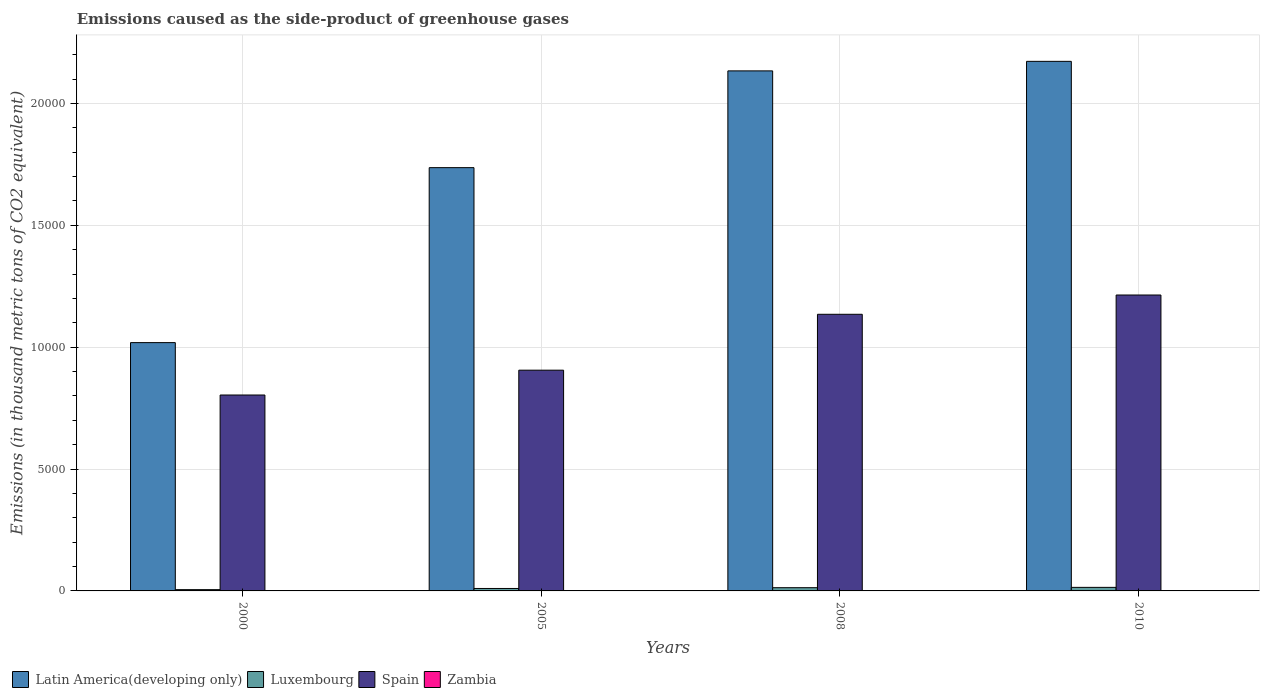How many different coloured bars are there?
Your answer should be very brief. 4. How many groups of bars are there?
Offer a terse response. 4. Are the number of bars on each tick of the X-axis equal?
Your answer should be compact. Yes. In how many cases, is the number of bars for a given year not equal to the number of legend labels?
Provide a short and direct response. 0. What is the emissions caused as the side-product of greenhouse gases in Spain in 2010?
Your answer should be compact. 1.21e+04. Across all years, what is the maximum emissions caused as the side-product of greenhouse gases in Latin America(developing only)?
Offer a terse response. 2.17e+04. What is the total emissions caused as the side-product of greenhouse gases in Zambia in the graph?
Your response must be concise. 2. What is the difference between the emissions caused as the side-product of greenhouse gases in Spain in 2000 and that in 2008?
Keep it short and to the point. -3310.7. What is the difference between the emissions caused as the side-product of greenhouse gases in Latin America(developing only) in 2008 and the emissions caused as the side-product of greenhouse gases in Spain in 2010?
Your answer should be very brief. 9193.8. What is the average emissions caused as the side-product of greenhouse gases in Luxembourg per year?
Offer a very short reply. 107.78. In the year 2005, what is the difference between the emissions caused as the side-product of greenhouse gases in Luxembourg and emissions caused as the side-product of greenhouse gases in Spain?
Make the answer very short. -8954.5. What is the ratio of the emissions caused as the side-product of greenhouse gases in Latin America(developing only) in 2005 to that in 2010?
Give a very brief answer. 0.8. What is the difference between the highest and the second highest emissions caused as the side-product of greenhouse gases in Spain?
Offer a very short reply. 791.2. What is the difference between the highest and the lowest emissions caused as the side-product of greenhouse gases in Latin America(developing only)?
Provide a succinct answer. 1.15e+04. Is the sum of the emissions caused as the side-product of greenhouse gases in Latin America(developing only) in 2008 and 2010 greater than the maximum emissions caused as the side-product of greenhouse gases in Luxembourg across all years?
Keep it short and to the point. Yes. What does the 4th bar from the left in 2000 represents?
Keep it short and to the point. Zambia. What does the 3rd bar from the right in 2008 represents?
Your answer should be very brief. Luxembourg. How many bars are there?
Provide a succinct answer. 16. Are all the bars in the graph horizontal?
Offer a terse response. No. How many years are there in the graph?
Provide a succinct answer. 4. Are the values on the major ticks of Y-axis written in scientific E-notation?
Give a very brief answer. No. Does the graph contain any zero values?
Keep it short and to the point. No. How are the legend labels stacked?
Offer a very short reply. Horizontal. What is the title of the graph?
Give a very brief answer. Emissions caused as the side-product of greenhouse gases. Does "Low & middle income" appear as one of the legend labels in the graph?
Keep it short and to the point. No. What is the label or title of the X-axis?
Your answer should be compact. Years. What is the label or title of the Y-axis?
Give a very brief answer. Emissions (in thousand metric tons of CO2 equivalent). What is the Emissions (in thousand metric tons of CO2 equivalent) in Latin America(developing only) in 2000?
Ensure brevity in your answer.  1.02e+04. What is the Emissions (in thousand metric tons of CO2 equivalent) in Luxembourg in 2000?
Your answer should be very brief. 52.1. What is the Emissions (in thousand metric tons of CO2 equivalent) in Spain in 2000?
Ensure brevity in your answer.  8037.1. What is the Emissions (in thousand metric tons of CO2 equivalent) in Latin America(developing only) in 2005?
Your response must be concise. 1.74e+04. What is the Emissions (in thousand metric tons of CO2 equivalent) in Luxembourg in 2005?
Provide a succinct answer. 100.6. What is the Emissions (in thousand metric tons of CO2 equivalent) of Spain in 2005?
Provide a short and direct response. 9055.1. What is the Emissions (in thousand metric tons of CO2 equivalent) in Zambia in 2005?
Give a very brief answer. 0.4. What is the Emissions (in thousand metric tons of CO2 equivalent) of Latin America(developing only) in 2008?
Provide a succinct answer. 2.13e+04. What is the Emissions (in thousand metric tons of CO2 equivalent) of Luxembourg in 2008?
Your answer should be compact. 132.4. What is the Emissions (in thousand metric tons of CO2 equivalent) of Spain in 2008?
Give a very brief answer. 1.13e+04. What is the Emissions (in thousand metric tons of CO2 equivalent) in Latin America(developing only) in 2010?
Keep it short and to the point. 2.17e+04. What is the Emissions (in thousand metric tons of CO2 equivalent) in Luxembourg in 2010?
Provide a succinct answer. 146. What is the Emissions (in thousand metric tons of CO2 equivalent) of Spain in 2010?
Your answer should be very brief. 1.21e+04. Across all years, what is the maximum Emissions (in thousand metric tons of CO2 equivalent) of Latin America(developing only)?
Your response must be concise. 2.17e+04. Across all years, what is the maximum Emissions (in thousand metric tons of CO2 equivalent) of Luxembourg?
Give a very brief answer. 146. Across all years, what is the maximum Emissions (in thousand metric tons of CO2 equivalent) of Spain?
Make the answer very short. 1.21e+04. Across all years, what is the maximum Emissions (in thousand metric tons of CO2 equivalent) of Zambia?
Offer a very short reply. 1. Across all years, what is the minimum Emissions (in thousand metric tons of CO2 equivalent) of Latin America(developing only)?
Your answer should be compact. 1.02e+04. Across all years, what is the minimum Emissions (in thousand metric tons of CO2 equivalent) of Luxembourg?
Your answer should be compact. 52.1. Across all years, what is the minimum Emissions (in thousand metric tons of CO2 equivalent) of Spain?
Provide a short and direct response. 8037.1. Across all years, what is the minimum Emissions (in thousand metric tons of CO2 equivalent) in Zambia?
Provide a succinct answer. 0.1. What is the total Emissions (in thousand metric tons of CO2 equivalent) in Latin America(developing only) in the graph?
Provide a succinct answer. 7.06e+04. What is the total Emissions (in thousand metric tons of CO2 equivalent) in Luxembourg in the graph?
Provide a succinct answer. 431.1. What is the total Emissions (in thousand metric tons of CO2 equivalent) of Spain in the graph?
Give a very brief answer. 4.06e+04. What is the difference between the Emissions (in thousand metric tons of CO2 equivalent) in Latin America(developing only) in 2000 and that in 2005?
Make the answer very short. -7177.9. What is the difference between the Emissions (in thousand metric tons of CO2 equivalent) of Luxembourg in 2000 and that in 2005?
Offer a terse response. -48.5. What is the difference between the Emissions (in thousand metric tons of CO2 equivalent) in Spain in 2000 and that in 2005?
Give a very brief answer. -1018. What is the difference between the Emissions (in thousand metric tons of CO2 equivalent) in Latin America(developing only) in 2000 and that in 2008?
Keep it short and to the point. -1.11e+04. What is the difference between the Emissions (in thousand metric tons of CO2 equivalent) of Luxembourg in 2000 and that in 2008?
Provide a succinct answer. -80.3. What is the difference between the Emissions (in thousand metric tons of CO2 equivalent) of Spain in 2000 and that in 2008?
Provide a short and direct response. -3310.7. What is the difference between the Emissions (in thousand metric tons of CO2 equivalent) in Zambia in 2000 and that in 2008?
Ensure brevity in your answer.  -0.4. What is the difference between the Emissions (in thousand metric tons of CO2 equivalent) in Latin America(developing only) in 2000 and that in 2010?
Keep it short and to the point. -1.15e+04. What is the difference between the Emissions (in thousand metric tons of CO2 equivalent) in Luxembourg in 2000 and that in 2010?
Provide a short and direct response. -93.9. What is the difference between the Emissions (in thousand metric tons of CO2 equivalent) of Spain in 2000 and that in 2010?
Offer a terse response. -4101.9. What is the difference between the Emissions (in thousand metric tons of CO2 equivalent) in Zambia in 2000 and that in 2010?
Your response must be concise. -0.9. What is the difference between the Emissions (in thousand metric tons of CO2 equivalent) of Latin America(developing only) in 2005 and that in 2008?
Your response must be concise. -3969.1. What is the difference between the Emissions (in thousand metric tons of CO2 equivalent) of Luxembourg in 2005 and that in 2008?
Ensure brevity in your answer.  -31.8. What is the difference between the Emissions (in thousand metric tons of CO2 equivalent) in Spain in 2005 and that in 2008?
Offer a very short reply. -2292.7. What is the difference between the Emissions (in thousand metric tons of CO2 equivalent) of Latin America(developing only) in 2005 and that in 2010?
Your answer should be compact. -4360.3. What is the difference between the Emissions (in thousand metric tons of CO2 equivalent) of Luxembourg in 2005 and that in 2010?
Your answer should be very brief. -45.4. What is the difference between the Emissions (in thousand metric tons of CO2 equivalent) of Spain in 2005 and that in 2010?
Your response must be concise. -3083.9. What is the difference between the Emissions (in thousand metric tons of CO2 equivalent) in Latin America(developing only) in 2008 and that in 2010?
Offer a terse response. -391.2. What is the difference between the Emissions (in thousand metric tons of CO2 equivalent) of Luxembourg in 2008 and that in 2010?
Your response must be concise. -13.6. What is the difference between the Emissions (in thousand metric tons of CO2 equivalent) in Spain in 2008 and that in 2010?
Offer a very short reply. -791.2. What is the difference between the Emissions (in thousand metric tons of CO2 equivalent) of Zambia in 2008 and that in 2010?
Provide a succinct answer. -0.5. What is the difference between the Emissions (in thousand metric tons of CO2 equivalent) in Latin America(developing only) in 2000 and the Emissions (in thousand metric tons of CO2 equivalent) in Luxembourg in 2005?
Your answer should be very brief. 1.01e+04. What is the difference between the Emissions (in thousand metric tons of CO2 equivalent) of Latin America(developing only) in 2000 and the Emissions (in thousand metric tons of CO2 equivalent) of Spain in 2005?
Your answer should be compact. 1130.7. What is the difference between the Emissions (in thousand metric tons of CO2 equivalent) in Latin America(developing only) in 2000 and the Emissions (in thousand metric tons of CO2 equivalent) in Zambia in 2005?
Offer a terse response. 1.02e+04. What is the difference between the Emissions (in thousand metric tons of CO2 equivalent) in Luxembourg in 2000 and the Emissions (in thousand metric tons of CO2 equivalent) in Spain in 2005?
Your answer should be very brief. -9003. What is the difference between the Emissions (in thousand metric tons of CO2 equivalent) of Luxembourg in 2000 and the Emissions (in thousand metric tons of CO2 equivalent) of Zambia in 2005?
Your answer should be very brief. 51.7. What is the difference between the Emissions (in thousand metric tons of CO2 equivalent) in Spain in 2000 and the Emissions (in thousand metric tons of CO2 equivalent) in Zambia in 2005?
Your answer should be compact. 8036.7. What is the difference between the Emissions (in thousand metric tons of CO2 equivalent) of Latin America(developing only) in 2000 and the Emissions (in thousand metric tons of CO2 equivalent) of Luxembourg in 2008?
Provide a succinct answer. 1.01e+04. What is the difference between the Emissions (in thousand metric tons of CO2 equivalent) in Latin America(developing only) in 2000 and the Emissions (in thousand metric tons of CO2 equivalent) in Spain in 2008?
Offer a very short reply. -1162. What is the difference between the Emissions (in thousand metric tons of CO2 equivalent) of Latin America(developing only) in 2000 and the Emissions (in thousand metric tons of CO2 equivalent) of Zambia in 2008?
Ensure brevity in your answer.  1.02e+04. What is the difference between the Emissions (in thousand metric tons of CO2 equivalent) of Luxembourg in 2000 and the Emissions (in thousand metric tons of CO2 equivalent) of Spain in 2008?
Your response must be concise. -1.13e+04. What is the difference between the Emissions (in thousand metric tons of CO2 equivalent) in Luxembourg in 2000 and the Emissions (in thousand metric tons of CO2 equivalent) in Zambia in 2008?
Make the answer very short. 51.6. What is the difference between the Emissions (in thousand metric tons of CO2 equivalent) in Spain in 2000 and the Emissions (in thousand metric tons of CO2 equivalent) in Zambia in 2008?
Give a very brief answer. 8036.6. What is the difference between the Emissions (in thousand metric tons of CO2 equivalent) in Latin America(developing only) in 2000 and the Emissions (in thousand metric tons of CO2 equivalent) in Luxembourg in 2010?
Your response must be concise. 1.00e+04. What is the difference between the Emissions (in thousand metric tons of CO2 equivalent) in Latin America(developing only) in 2000 and the Emissions (in thousand metric tons of CO2 equivalent) in Spain in 2010?
Your answer should be very brief. -1953.2. What is the difference between the Emissions (in thousand metric tons of CO2 equivalent) of Latin America(developing only) in 2000 and the Emissions (in thousand metric tons of CO2 equivalent) of Zambia in 2010?
Your answer should be very brief. 1.02e+04. What is the difference between the Emissions (in thousand metric tons of CO2 equivalent) of Luxembourg in 2000 and the Emissions (in thousand metric tons of CO2 equivalent) of Spain in 2010?
Your response must be concise. -1.21e+04. What is the difference between the Emissions (in thousand metric tons of CO2 equivalent) in Luxembourg in 2000 and the Emissions (in thousand metric tons of CO2 equivalent) in Zambia in 2010?
Your answer should be compact. 51.1. What is the difference between the Emissions (in thousand metric tons of CO2 equivalent) in Spain in 2000 and the Emissions (in thousand metric tons of CO2 equivalent) in Zambia in 2010?
Make the answer very short. 8036.1. What is the difference between the Emissions (in thousand metric tons of CO2 equivalent) of Latin America(developing only) in 2005 and the Emissions (in thousand metric tons of CO2 equivalent) of Luxembourg in 2008?
Offer a terse response. 1.72e+04. What is the difference between the Emissions (in thousand metric tons of CO2 equivalent) of Latin America(developing only) in 2005 and the Emissions (in thousand metric tons of CO2 equivalent) of Spain in 2008?
Ensure brevity in your answer.  6015.9. What is the difference between the Emissions (in thousand metric tons of CO2 equivalent) in Latin America(developing only) in 2005 and the Emissions (in thousand metric tons of CO2 equivalent) in Zambia in 2008?
Ensure brevity in your answer.  1.74e+04. What is the difference between the Emissions (in thousand metric tons of CO2 equivalent) in Luxembourg in 2005 and the Emissions (in thousand metric tons of CO2 equivalent) in Spain in 2008?
Keep it short and to the point. -1.12e+04. What is the difference between the Emissions (in thousand metric tons of CO2 equivalent) of Luxembourg in 2005 and the Emissions (in thousand metric tons of CO2 equivalent) of Zambia in 2008?
Ensure brevity in your answer.  100.1. What is the difference between the Emissions (in thousand metric tons of CO2 equivalent) of Spain in 2005 and the Emissions (in thousand metric tons of CO2 equivalent) of Zambia in 2008?
Your response must be concise. 9054.6. What is the difference between the Emissions (in thousand metric tons of CO2 equivalent) of Latin America(developing only) in 2005 and the Emissions (in thousand metric tons of CO2 equivalent) of Luxembourg in 2010?
Your answer should be very brief. 1.72e+04. What is the difference between the Emissions (in thousand metric tons of CO2 equivalent) in Latin America(developing only) in 2005 and the Emissions (in thousand metric tons of CO2 equivalent) in Spain in 2010?
Your response must be concise. 5224.7. What is the difference between the Emissions (in thousand metric tons of CO2 equivalent) in Latin America(developing only) in 2005 and the Emissions (in thousand metric tons of CO2 equivalent) in Zambia in 2010?
Make the answer very short. 1.74e+04. What is the difference between the Emissions (in thousand metric tons of CO2 equivalent) in Luxembourg in 2005 and the Emissions (in thousand metric tons of CO2 equivalent) in Spain in 2010?
Your answer should be compact. -1.20e+04. What is the difference between the Emissions (in thousand metric tons of CO2 equivalent) in Luxembourg in 2005 and the Emissions (in thousand metric tons of CO2 equivalent) in Zambia in 2010?
Your response must be concise. 99.6. What is the difference between the Emissions (in thousand metric tons of CO2 equivalent) of Spain in 2005 and the Emissions (in thousand metric tons of CO2 equivalent) of Zambia in 2010?
Offer a terse response. 9054.1. What is the difference between the Emissions (in thousand metric tons of CO2 equivalent) of Latin America(developing only) in 2008 and the Emissions (in thousand metric tons of CO2 equivalent) of Luxembourg in 2010?
Give a very brief answer. 2.12e+04. What is the difference between the Emissions (in thousand metric tons of CO2 equivalent) of Latin America(developing only) in 2008 and the Emissions (in thousand metric tons of CO2 equivalent) of Spain in 2010?
Keep it short and to the point. 9193.8. What is the difference between the Emissions (in thousand metric tons of CO2 equivalent) of Latin America(developing only) in 2008 and the Emissions (in thousand metric tons of CO2 equivalent) of Zambia in 2010?
Offer a terse response. 2.13e+04. What is the difference between the Emissions (in thousand metric tons of CO2 equivalent) of Luxembourg in 2008 and the Emissions (in thousand metric tons of CO2 equivalent) of Spain in 2010?
Keep it short and to the point. -1.20e+04. What is the difference between the Emissions (in thousand metric tons of CO2 equivalent) in Luxembourg in 2008 and the Emissions (in thousand metric tons of CO2 equivalent) in Zambia in 2010?
Make the answer very short. 131.4. What is the difference between the Emissions (in thousand metric tons of CO2 equivalent) in Spain in 2008 and the Emissions (in thousand metric tons of CO2 equivalent) in Zambia in 2010?
Your answer should be very brief. 1.13e+04. What is the average Emissions (in thousand metric tons of CO2 equivalent) in Latin America(developing only) per year?
Give a very brief answer. 1.77e+04. What is the average Emissions (in thousand metric tons of CO2 equivalent) in Luxembourg per year?
Offer a very short reply. 107.78. What is the average Emissions (in thousand metric tons of CO2 equivalent) in Spain per year?
Keep it short and to the point. 1.01e+04. In the year 2000, what is the difference between the Emissions (in thousand metric tons of CO2 equivalent) in Latin America(developing only) and Emissions (in thousand metric tons of CO2 equivalent) in Luxembourg?
Provide a succinct answer. 1.01e+04. In the year 2000, what is the difference between the Emissions (in thousand metric tons of CO2 equivalent) of Latin America(developing only) and Emissions (in thousand metric tons of CO2 equivalent) of Spain?
Offer a very short reply. 2148.7. In the year 2000, what is the difference between the Emissions (in thousand metric tons of CO2 equivalent) in Latin America(developing only) and Emissions (in thousand metric tons of CO2 equivalent) in Zambia?
Give a very brief answer. 1.02e+04. In the year 2000, what is the difference between the Emissions (in thousand metric tons of CO2 equivalent) of Luxembourg and Emissions (in thousand metric tons of CO2 equivalent) of Spain?
Your response must be concise. -7985. In the year 2000, what is the difference between the Emissions (in thousand metric tons of CO2 equivalent) in Spain and Emissions (in thousand metric tons of CO2 equivalent) in Zambia?
Your answer should be compact. 8037. In the year 2005, what is the difference between the Emissions (in thousand metric tons of CO2 equivalent) in Latin America(developing only) and Emissions (in thousand metric tons of CO2 equivalent) in Luxembourg?
Give a very brief answer. 1.73e+04. In the year 2005, what is the difference between the Emissions (in thousand metric tons of CO2 equivalent) of Latin America(developing only) and Emissions (in thousand metric tons of CO2 equivalent) of Spain?
Your response must be concise. 8308.6. In the year 2005, what is the difference between the Emissions (in thousand metric tons of CO2 equivalent) in Latin America(developing only) and Emissions (in thousand metric tons of CO2 equivalent) in Zambia?
Keep it short and to the point. 1.74e+04. In the year 2005, what is the difference between the Emissions (in thousand metric tons of CO2 equivalent) of Luxembourg and Emissions (in thousand metric tons of CO2 equivalent) of Spain?
Offer a terse response. -8954.5. In the year 2005, what is the difference between the Emissions (in thousand metric tons of CO2 equivalent) in Luxembourg and Emissions (in thousand metric tons of CO2 equivalent) in Zambia?
Your response must be concise. 100.2. In the year 2005, what is the difference between the Emissions (in thousand metric tons of CO2 equivalent) of Spain and Emissions (in thousand metric tons of CO2 equivalent) of Zambia?
Make the answer very short. 9054.7. In the year 2008, what is the difference between the Emissions (in thousand metric tons of CO2 equivalent) in Latin America(developing only) and Emissions (in thousand metric tons of CO2 equivalent) in Luxembourg?
Provide a short and direct response. 2.12e+04. In the year 2008, what is the difference between the Emissions (in thousand metric tons of CO2 equivalent) of Latin America(developing only) and Emissions (in thousand metric tons of CO2 equivalent) of Spain?
Give a very brief answer. 9985. In the year 2008, what is the difference between the Emissions (in thousand metric tons of CO2 equivalent) in Latin America(developing only) and Emissions (in thousand metric tons of CO2 equivalent) in Zambia?
Offer a terse response. 2.13e+04. In the year 2008, what is the difference between the Emissions (in thousand metric tons of CO2 equivalent) of Luxembourg and Emissions (in thousand metric tons of CO2 equivalent) of Spain?
Your answer should be compact. -1.12e+04. In the year 2008, what is the difference between the Emissions (in thousand metric tons of CO2 equivalent) in Luxembourg and Emissions (in thousand metric tons of CO2 equivalent) in Zambia?
Provide a short and direct response. 131.9. In the year 2008, what is the difference between the Emissions (in thousand metric tons of CO2 equivalent) in Spain and Emissions (in thousand metric tons of CO2 equivalent) in Zambia?
Keep it short and to the point. 1.13e+04. In the year 2010, what is the difference between the Emissions (in thousand metric tons of CO2 equivalent) of Latin America(developing only) and Emissions (in thousand metric tons of CO2 equivalent) of Luxembourg?
Offer a terse response. 2.16e+04. In the year 2010, what is the difference between the Emissions (in thousand metric tons of CO2 equivalent) of Latin America(developing only) and Emissions (in thousand metric tons of CO2 equivalent) of Spain?
Make the answer very short. 9585. In the year 2010, what is the difference between the Emissions (in thousand metric tons of CO2 equivalent) in Latin America(developing only) and Emissions (in thousand metric tons of CO2 equivalent) in Zambia?
Provide a succinct answer. 2.17e+04. In the year 2010, what is the difference between the Emissions (in thousand metric tons of CO2 equivalent) in Luxembourg and Emissions (in thousand metric tons of CO2 equivalent) in Spain?
Make the answer very short. -1.20e+04. In the year 2010, what is the difference between the Emissions (in thousand metric tons of CO2 equivalent) of Luxembourg and Emissions (in thousand metric tons of CO2 equivalent) of Zambia?
Your answer should be very brief. 145. In the year 2010, what is the difference between the Emissions (in thousand metric tons of CO2 equivalent) of Spain and Emissions (in thousand metric tons of CO2 equivalent) of Zambia?
Your answer should be compact. 1.21e+04. What is the ratio of the Emissions (in thousand metric tons of CO2 equivalent) of Latin America(developing only) in 2000 to that in 2005?
Make the answer very short. 0.59. What is the ratio of the Emissions (in thousand metric tons of CO2 equivalent) in Luxembourg in 2000 to that in 2005?
Your response must be concise. 0.52. What is the ratio of the Emissions (in thousand metric tons of CO2 equivalent) in Spain in 2000 to that in 2005?
Your answer should be compact. 0.89. What is the ratio of the Emissions (in thousand metric tons of CO2 equivalent) in Zambia in 2000 to that in 2005?
Provide a short and direct response. 0.25. What is the ratio of the Emissions (in thousand metric tons of CO2 equivalent) of Latin America(developing only) in 2000 to that in 2008?
Your answer should be compact. 0.48. What is the ratio of the Emissions (in thousand metric tons of CO2 equivalent) in Luxembourg in 2000 to that in 2008?
Offer a terse response. 0.39. What is the ratio of the Emissions (in thousand metric tons of CO2 equivalent) in Spain in 2000 to that in 2008?
Your response must be concise. 0.71. What is the ratio of the Emissions (in thousand metric tons of CO2 equivalent) of Latin America(developing only) in 2000 to that in 2010?
Your answer should be compact. 0.47. What is the ratio of the Emissions (in thousand metric tons of CO2 equivalent) in Luxembourg in 2000 to that in 2010?
Provide a short and direct response. 0.36. What is the ratio of the Emissions (in thousand metric tons of CO2 equivalent) of Spain in 2000 to that in 2010?
Your answer should be very brief. 0.66. What is the ratio of the Emissions (in thousand metric tons of CO2 equivalent) of Zambia in 2000 to that in 2010?
Provide a short and direct response. 0.1. What is the ratio of the Emissions (in thousand metric tons of CO2 equivalent) in Latin America(developing only) in 2005 to that in 2008?
Provide a short and direct response. 0.81. What is the ratio of the Emissions (in thousand metric tons of CO2 equivalent) in Luxembourg in 2005 to that in 2008?
Provide a short and direct response. 0.76. What is the ratio of the Emissions (in thousand metric tons of CO2 equivalent) in Spain in 2005 to that in 2008?
Make the answer very short. 0.8. What is the ratio of the Emissions (in thousand metric tons of CO2 equivalent) in Latin America(developing only) in 2005 to that in 2010?
Offer a terse response. 0.8. What is the ratio of the Emissions (in thousand metric tons of CO2 equivalent) of Luxembourg in 2005 to that in 2010?
Your answer should be compact. 0.69. What is the ratio of the Emissions (in thousand metric tons of CO2 equivalent) of Spain in 2005 to that in 2010?
Make the answer very short. 0.75. What is the ratio of the Emissions (in thousand metric tons of CO2 equivalent) of Latin America(developing only) in 2008 to that in 2010?
Provide a succinct answer. 0.98. What is the ratio of the Emissions (in thousand metric tons of CO2 equivalent) of Luxembourg in 2008 to that in 2010?
Keep it short and to the point. 0.91. What is the ratio of the Emissions (in thousand metric tons of CO2 equivalent) of Spain in 2008 to that in 2010?
Your answer should be very brief. 0.93. What is the ratio of the Emissions (in thousand metric tons of CO2 equivalent) of Zambia in 2008 to that in 2010?
Ensure brevity in your answer.  0.5. What is the difference between the highest and the second highest Emissions (in thousand metric tons of CO2 equivalent) in Latin America(developing only)?
Offer a very short reply. 391.2. What is the difference between the highest and the second highest Emissions (in thousand metric tons of CO2 equivalent) in Luxembourg?
Give a very brief answer. 13.6. What is the difference between the highest and the second highest Emissions (in thousand metric tons of CO2 equivalent) of Spain?
Offer a very short reply. 791.2. What is the difference between the highest and the lowest Emissions (in thousand metric tons of CO2 equivalent) in Latin America(developing only)?
Keep it short and to the point. 1.15e+04. What is the difference between the highest and the lowest Emissions (in thousand metric tons of CO2 equivalent) of Luxembourg?
Provide a short and direct response. 93.9. What is the difference between the highest and the lowest Emissions (in thousand metric tons of CO2 equivalent) in Spain?
Give a very brief answer. 4101.9. What is the difference between the highest and the lowest Emissions (in thousand metric tons of CO2 equivalent) in Zambia?
Offer a very short reply. 0.9. 